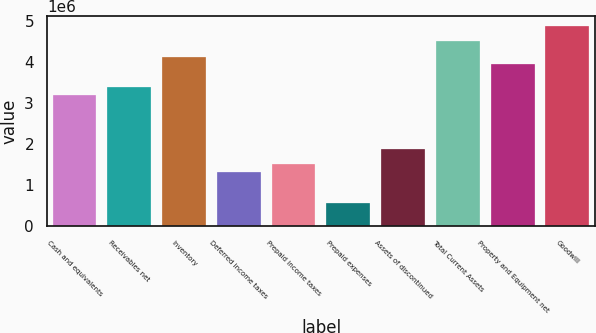<chart> <loc_0><loc_0><loc_500><loc_500><bar_chart><fcel>Cash and equivalents<fcel>Receivables net<fcel>Inventory<fcel>Deferred income taxes<fcel>Prepaid income taxes<fcel>Prepaid expenses<fcel>Assets of discontinued<fcel>Total Current Assets<fcel>Property and Equipment net<fcel>Goodwill<nl><fcel>3.19882e+06<fcel>3.38696e+06<fcel>4.13954e+06<fcel>1.31737e+06<fcel>1.50551e+06<fcel>564789<fcel>1.8818e+06<fcel>4.51583e+06<fcel>3.9514e+06<fcel>4.89212e+06<nl></chart> 